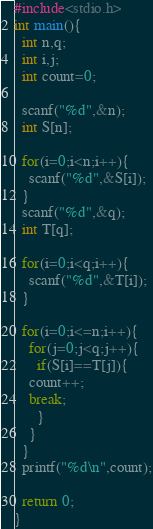Convert code to text. <code><loc_0><loc_0><loc_500><loc_500><_C_>#include<stdio.h>
int main(){
  int n,q;
  int i,j;
  int count=0;
 
  scanf("%d",&n);
  int S[n];
  
  for(i=0;i<n;i++){
    scanf("%d",&S[i]);
  }
  scanf("%d",&q);
  int T[q];

  for(i=0;i<q;i++){
    scanf("%d",&T[i]);
  }

  for(i=0;i<=n;i++){
    for(j=0;j<q;j++){
      if(S[i]==T[j]){
	count++;
	break;
      }
    }
  }
  printf("%d\n",count);

  return 0;
}

</code> 